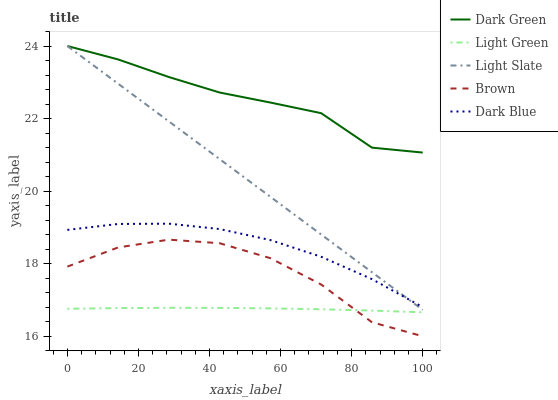Does Brown have the minimum area under the curve?
Answer yes or no. No. Does Brown have the maximum area under the curve?
Answer yes or no. No. Is Dark Blue the smoothest?
Answer yes or no. No. Is Dark Blue the roughest?
Answer yes or no. No. Does Dark Blue have the lowest value?
Answer yes or no. No. Does Brown have the highest value?
Answer yes or no. No. Is Light Green less than Dark Green?
Answer yes or no. Yes. Is Dark Blue greater than Light Green?
Answer yes or no. Yes. Does Light Green intersect Dark Green?
Answer yes or no. No. 